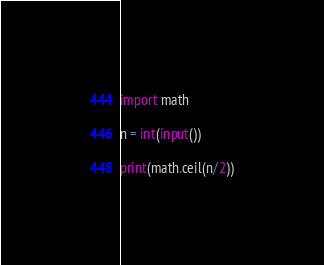Convert code to text. <code><loc_0><loc_0><loc_500><loc_500><_Python_>import math

n = int(input())

print(math.ceil(n/2))</code> 